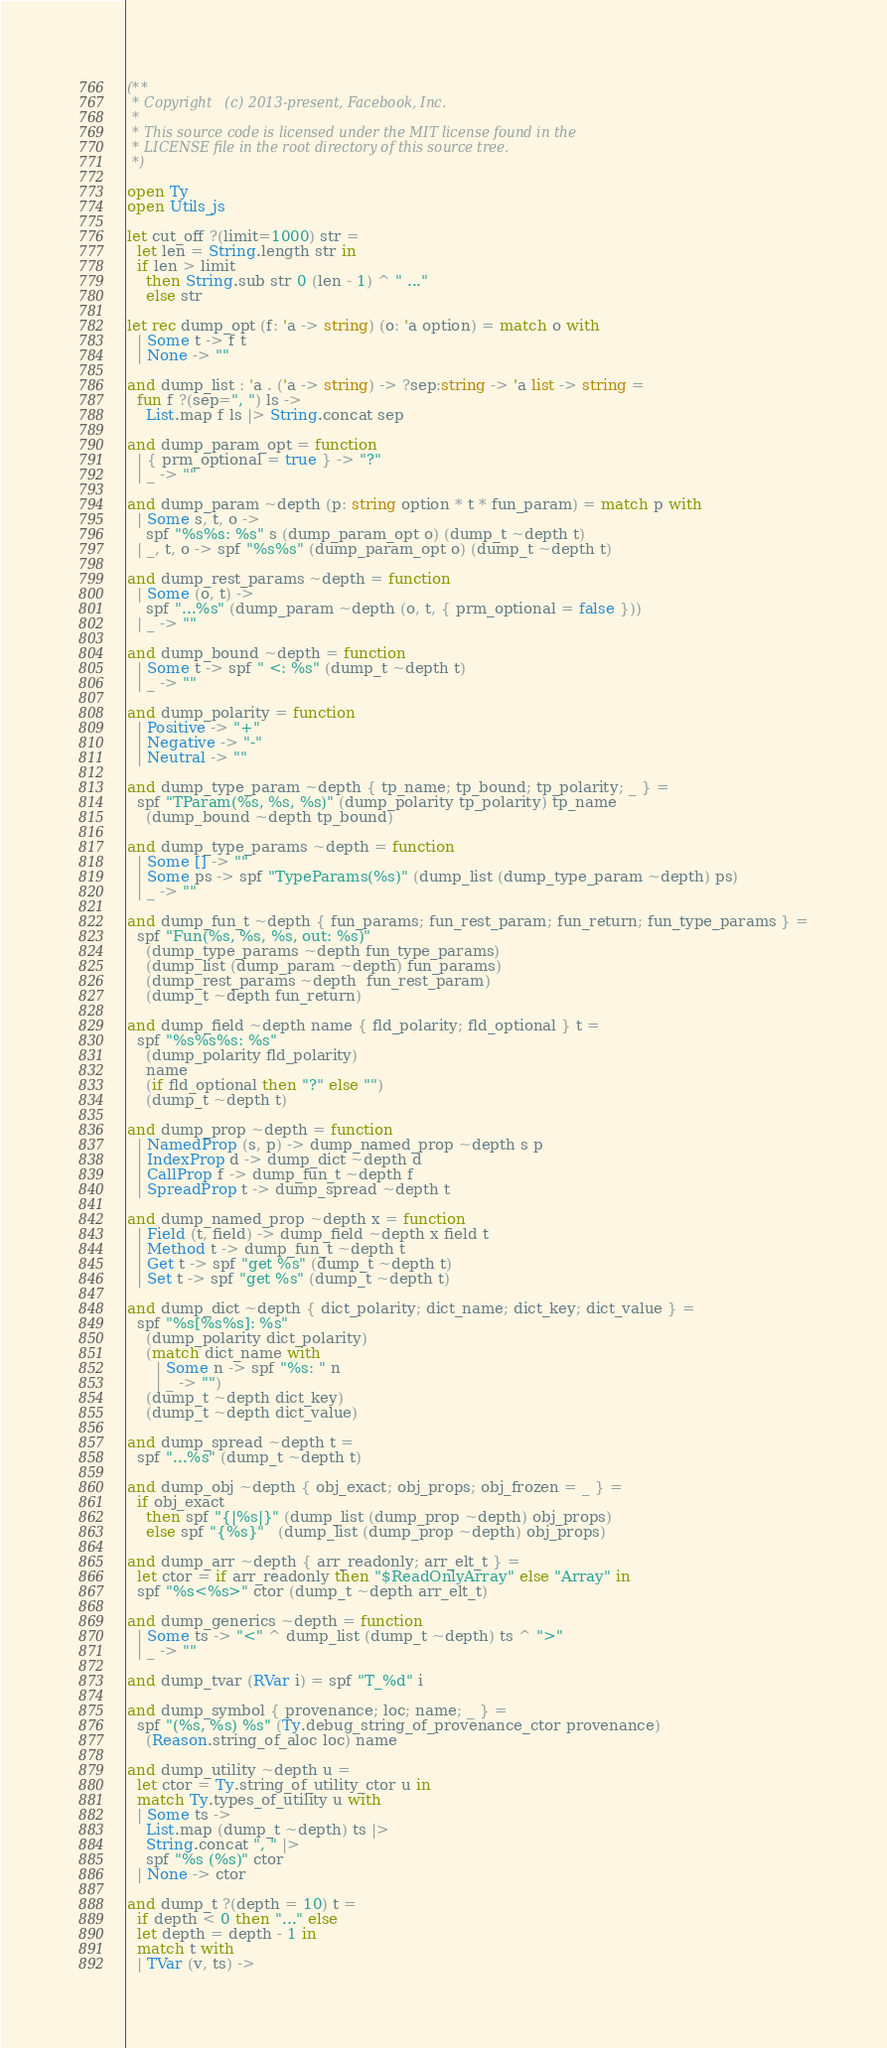Convert code to text. <code><loc_0><loc_0><loc_500><loc_500><_OCaml_>(**
 * Copyright (c) 2013-present, Facebook, Inc.
 *
 * This source code is licensed under the MIT license found in the
 * LICENSE file in the root directory of this source tree.
 *)

open Ty
open Utils_js

let cut_off ?(limit=1000) str =
  let len = String.length str in
  if len > limit
    then String.sub str 0 (len - 1) ^ " ..."
    else str

let rec dump_opt (f: 'a -> string) (o: 'a option) = match o with
  | Some t -> f t
  | None -> ""

and dump_list : 'a . ('a -> string) -> ?sep:string -> 'a list -> string =
  fun f ?(sep=", ") ls ->
    List.map f ls |> String.concat sep

and dump_param_opt = function
  | { prm_optional = true } -> "?"
  | _ -> ""

and dump_param ~depth (p: string option * t * fun_param) = match p with
  | Some s, t, o ->
    spf "%s%s: %s" s (dump_param_opt o) (dump_t ~depth t)
  | _, t, o -> spf "%s%s" (dump_param_opt o) (dump_t ~depth t)

and dump_rest_params ~depth = function
  | Some (o, t) ->
    spf "...%s" (dump_param ~depth (o, t, { prm_optional = false }))
  | _ -> ""

and dump_bound ~depth = function
  | Some t -> spf " <: %s" (dump_t ~depth t)
  | _ -> ""

and dump_polarity = function
  | Positive -> "+"
  | Negative -> "-"
  | Neutral -> ""

and dump_type_param ~depth { tp_name; tp_bound; tp_polarity; _ } =
  spf "TParam(%s, %s, %s)" (dump_polarity tp_polarity) tp_name
    (dump_bound ~depth tp_bound)

and dump_type_params ~depth = function
  | Some [] -> ""
  | Some ps -> spf "TypeParams(%s)" (dump_list (dump_type_param ~depth) ps)
  | _ -> ""

and dump_fun_t ~depth { fun_params; fun_rest_param; fun_return; fun_type_params } =
  spf "Fun(%s, %s, %s, out: %s)"
    (dump_type_params ~depth fun_type_params)
    (dump_list (dump_param ~depth) fun_params)
    (dump_rest_params ~depth  fun_rest_param)
    (dump_t ~depth fun_return)

and dump_field ~depth name { fld_polarity; fld_optional } t =
  spf "%s%s%s: %s"
    (dump_polarity fld_polarity)
    name
    (if fld_optional then "?" else "")
    (dump_t ~depth t)

and dump_prop ~depth = function
  | NamedProp (s, p) -> dump_named_prop ~depth s p
  | IndexProp d -> dump_dict ~depth d
  | CallProp f -> dump_fun_t ~depth f
  | SpreadProp t -> dump_spread ~depth t

and dump_named_prop ~depth x = function
  | Field (t, field) -> dump_field ~depth x field t
  | Method t -> dump_fun_t ~depth t
  | Get t -> spf "get %s" (dump_t ~depth t)
  | Set t -> spf "get %s" (dump_t ~depth t)

and dump_dict ~depth { dict_polarity; dict_name; dict_key; dict_value } =
  spf "%s[%s%s]: %s"
    (dump_polarity dict_polarity)
    (match dict_name with
      | Some n -> spf "%s: " n
      | _ -> "")
    (dump_t ~depth dict_key)
    (dump_t ~depth dict_value)

and dump_spread ~depth t =
  spf "...%s" (dump_t ~depth t)

and dump_obj ~depth { obj_exact; obj_props; obj_frozen = _ } =
  if obj_exact
    then spf "{|%s|}" (dump_list (dump_prop ~depth) obj_props)
    else spf "{%s}"   (dump_list (dump_prop ~depth) obj_props)

and dump_arr ~depth { arr_readonly; arr_elt_t } =
  let ctor = if arr_readonly then "$ReadOnlyArray" else "Array" in
  spf "%s<%s>" ctor (dump_t ~depth arr_elt_t)

and dump_generics ~depth = function
  | Some ts -> "<" ^ dump_list (dump_t ~depth) ts ^ ">"
  | _ -> ""

and dump_tvar (RVar i) = spf "T_%d" i

and dump_symbol { provenance; loc; name; _ } =
  spf "(%s, %s) %s" (Ty.debug_string_of_provenance_ctor provenance)
    (Reason.string_of_aloc loc) name

and dump_utility ~depth u =
  let ctor = Ty.string_of_utility_ctor u in
  match Ty.types_of_utility u with
  | Some ts ->
    List.map (dump_t ~depth) ts |>
    String.concat ", " |>
    spf "%s (%s)" ctor
  | None -> ctor

and dump_t ?(depth = 10) t =
  if depth < 0 then "..." else
  let depth = depth - 1 in
  match t with
  | TVar (v, ts) -></code> 